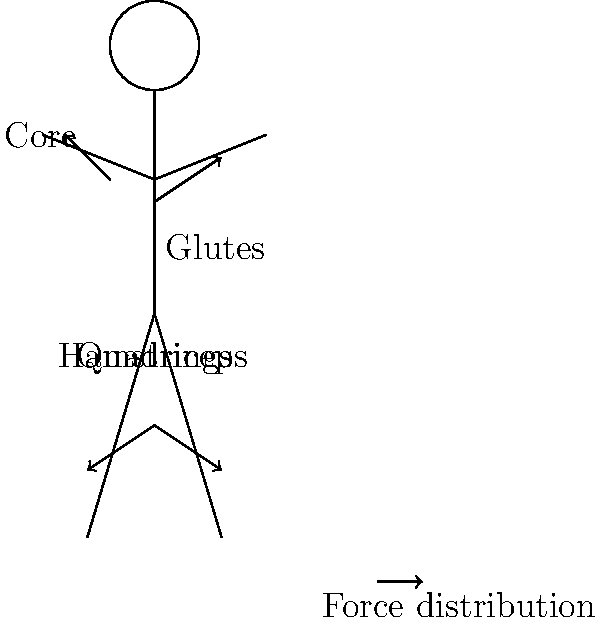During a squat exercise, which muscle group bears the highest percentage of force distribution, and how does this relate to overall body mechanics and injury prevention in a workplace setting? To understand force distribution during a squat exercise and its relevance to workplace ergonomics:

1. Quadriceps: Bear approximately 40-50% of the force. They're the primary movers in extending the knee joint.

2. Glutes: Take on about 25-30% of the force. They're crucial for hip extension and maintaining proper posture.

3. Hamstrings: Handle roughly 10-15% of the force. They assist in hip extension and provide knee stability.

4. Core muscles: Account for about 10-15% of force distribution. They stabilize the spine and maintain balance.

5. Other muscles (calves, lower back): Contribute the remaining 5-10%.

The quadriceps bear the highest percentage of force due to their role in knee extension, which is the primary movement in a squat.

Relevance to workplace setting:
1. Proper squatting technique mimics safe lifting practices in the workplace.
2. Understanding force distribution helps in designing ergonomic workstations and tools.
3. Strengthening these muscle groups through exercises like squats can reduce the risk of workplace injuries, particularly in jobs requiring lifting or bending.
4. Awareness of muscle engagement promotes better body mechanics during daily tasks.

By focusing on the quadriceps' role and overall muscle engagement, managers can implement better training programs for injury prevention and ergonomic practices in the workplace.
Answer: Quadriceps (40-50% of force) 